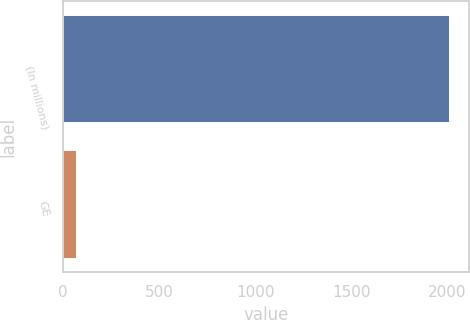Convert chart. <chart><loc_0><loc_0><loc_500><loc_500><bar_chart><fcel>(In millions)<fcel>GE<nl><fcel>2014<fcel>70<nl></chart> 